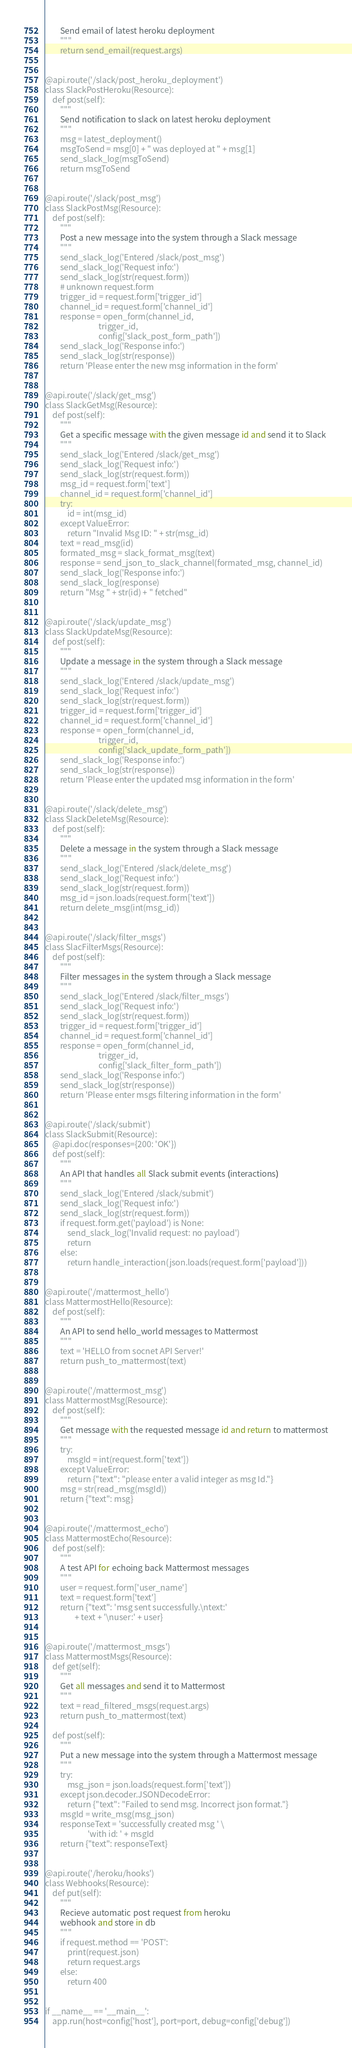Convert code to text. <code><loc_0><loc_0><loc_500><loc_500><_Python_>        Send email of latest heroku deployment
        """
        return send_email(request.args)


@api.route('/slack/post_heroku_deployment')
class SlackPostHeroku(Resource):
    def post(self):
        """
        Send notification to slack on latest heroku deployment
        """
        msg = latest_deployment()
        msgToSend = msg[0] + " was deployed at " + msg[1]
        send_slack_log(msgToSend)
        return msgToSend


@api.route('/slack/post_msg')
class SlackPostMsg(Resource):
    def post(self):
        """
        Post a new message into the system through a Slack message
        """
        send_slack_log('Entered /slack/post_msg')
        send_slack_log('Request info:')
        send_slack_log(str(request.form))
        # unknown request.form
        trigger_id = request.form['trigger_id']
        channel_id = request.form['channel_id']
        response = open_form(channel_id,
                             trigger_id,
                             config['slack_post_form_path'])
        send_slack_log('Response info:')
        send_slack_log(str(response))
        return 'Please enter the new msg information in the form'


@api.route('/slack/get_msg')
class SlackGetMsg(Resource):
    def post(self):
        """
        Get a specific message with the given message id and send it to Slack
        """
        send_slack_log('Entered /slack/get_msg')
        send_slack_log('Request info:')
        send_slack_log(str(request.form))
        msg_id = request.form['text']
        channel_id = request.form['channel_id']
        try:
            id = int(msg_id)
        except ValueError:
            return "Invalid Msg ID: " + str(msg_id)
        text = read_msg(id)
        formated_msg = slack_format_msg(text)
        response = send_json_to_slack_channel(formated_msg, channel_id)
        send_slack_log('Response info:')
        send_slack_log(response)
        return "Msg " + str(id) + " fetched"


@api.route('/slack/update_msg')
class SlackUpdateMsg(Resource):
    def post(self):
        """
        Update a message in the system through a Slack message
        """
        send_slack_log('Entered /slack/update_msg')
        send_slack_log('Request info:')
        send_slack_log(str(request.form))
        trigger_id = request.form['trigger_id']
        channel_id = request.form['channel_id']
        response = open_form(channel_id,
                             trigger_id,
                             config['slack_update_form_path'])
        send_slack_log('Response info:')
        send_slack_log(str(response))
        return 'Please enter the updated msg information in the form'


@api.route('/slack/delete_msg')
class SlackDeleteMsg(Resource):
    def post(self):
        """
        Delete a message in the system through a Slack message
        """
        send_slack_log('Entered /slack/delete_msg')
        send_slack_log('Request info:')
        send_slack_log(str(request.form))
        msg_id = json.loads(request.form['text'])
        return delete_msg(int(msg_id))


@api.route('/slack/filter_msgs')
class SlacFilterMsgs(Resource):
    def post(self):
        """
        Filter messages in the system through a Slack message
        """
        send_slack_log('Entered /slack/filter_msgs')
        send_slack_log('Request info:')
        send_slack_log(str(request.form))
        trigger_id = request.form['trigger_id']
        channel_id = request.form['channel_id']
        response = open_form(channel_id,
                             trigger_id,
                             config['slack_filter_form_path'])
        send_slack_log('Response info:')
        send_slack_log(str(response))
        return 'Please enter msgs filtering information in the form'


@api.route('/slack/submit')
class SlackSubmit(Resource):
    @api.doc(responses={200: 'OK'})
    def post(self):
        """
        An API that handles all Slack submit events (interactions)
        """
        send_slack_log('Entered /slack/submit')
        send_slack_log('Request info:')
        send_slack_log(str(request.form))
        if request.form.get('payload') is None:
            send_slack_log('Invalid request: no payload')
            return
        else:
            return handle_interaction(json.loads(request.form['payload']))


@api.route('/mattermost_hello')
class MattermostHello(Resource):
    def post(self):
        """
        An API to send hello_world messages to Mattermost
        """
        text = 'HELLO from socnet API Server!'
        return push_to_mattermost(text)


@api.route('/mattermost_msg')
class MattermostMsg(Resource):
    def post(self):
        """
        Get message with the requested message id and return to mattermost
        """
        try:
            msgId = int(request.form['text'])
        except ValueError:
            return {"text": "please enter a valid integer as msg Id."}
        msg = str(read_msg(msgId))
        return {"text": msg}


@api.route('/mattermost_echo')
class MattermostEcho(Resource):
    def post(self):
        """
        A test API for echoing back Mattermost messages
        """
        user = request.form['user_name']
        text = request.form['text']
        return {"text": 'msg sent successfully.\ntext:'
                + text + '\nuser:' + user}


@api.route('/mattermost_msgs')
class MattermostMsgs(Resource):
    def get(self):
        """
        Get all messages and send it to Mattermost
        """
        text = read_filtered_msgs(request.args)
        return push_to_mattermost(text)

    def post(self):
        """
        Put a new message into the system through a Mattermost message
        """
        try:
            msg_json = json.loads(request.form['text'])
        except json.decoder.JSONDecodeError:
            return {"text": "Failed to send msg. Incorrect json format."}
        msgId = write_msg(msg_json)
        responseText = 'successfully created msg ' \
                       'with id: ' + msgId
        return {"text": responseText}


@api.route('/heroku/hooks')
class Webhooks(Resource):
    def put(self):
        """
        Recieve automatic post request from heroku
        webhook and store in db
        """
        if request.method == 'POST':
            print(request.json)
            return request.args
        else:
            return 400


if __name__ == '__main__':
    app.run(host=config['host'], port=port, debug=config['debug'])
</code> 